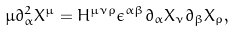<formula> <loc_0><loc_0><loc_500><loc_500>\mu \partial _ { \alpha } ^ { 2 } X ^ { \mu } = H ^ { \mu \nu \rho } \epsilon ^ { \alpha \beta } \partial _ { \alpha } X _ { \nu } \partial _ { \beta } X _ { \rho } ,</formula> 